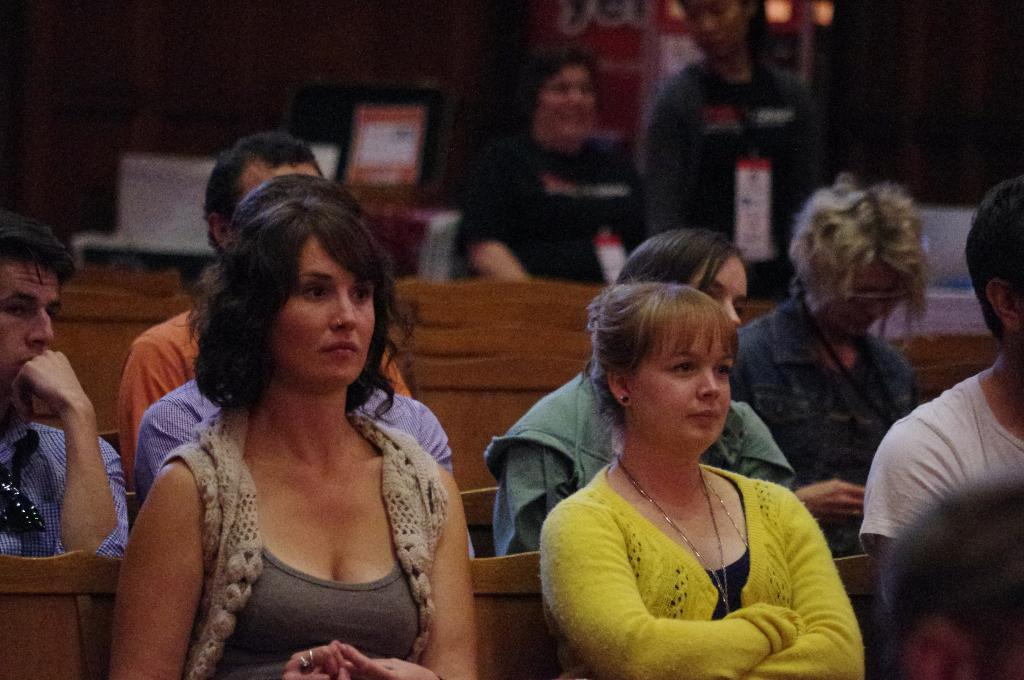What are the people in the image doing? The people in the image are sitting. Can you describe the position of the person at the back in the image? There is a person standing at the back in the image. What level of detail can be seen in the recess of the image? There is no recess present in the image, so it is not possible to determine the level of detail in it. 